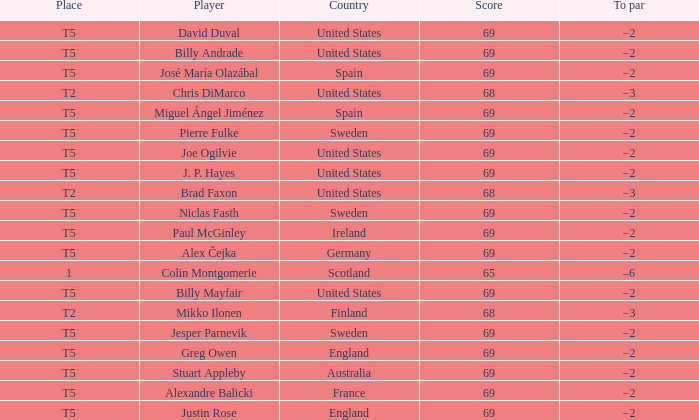What place did Paul McGinley finish in? T5. 